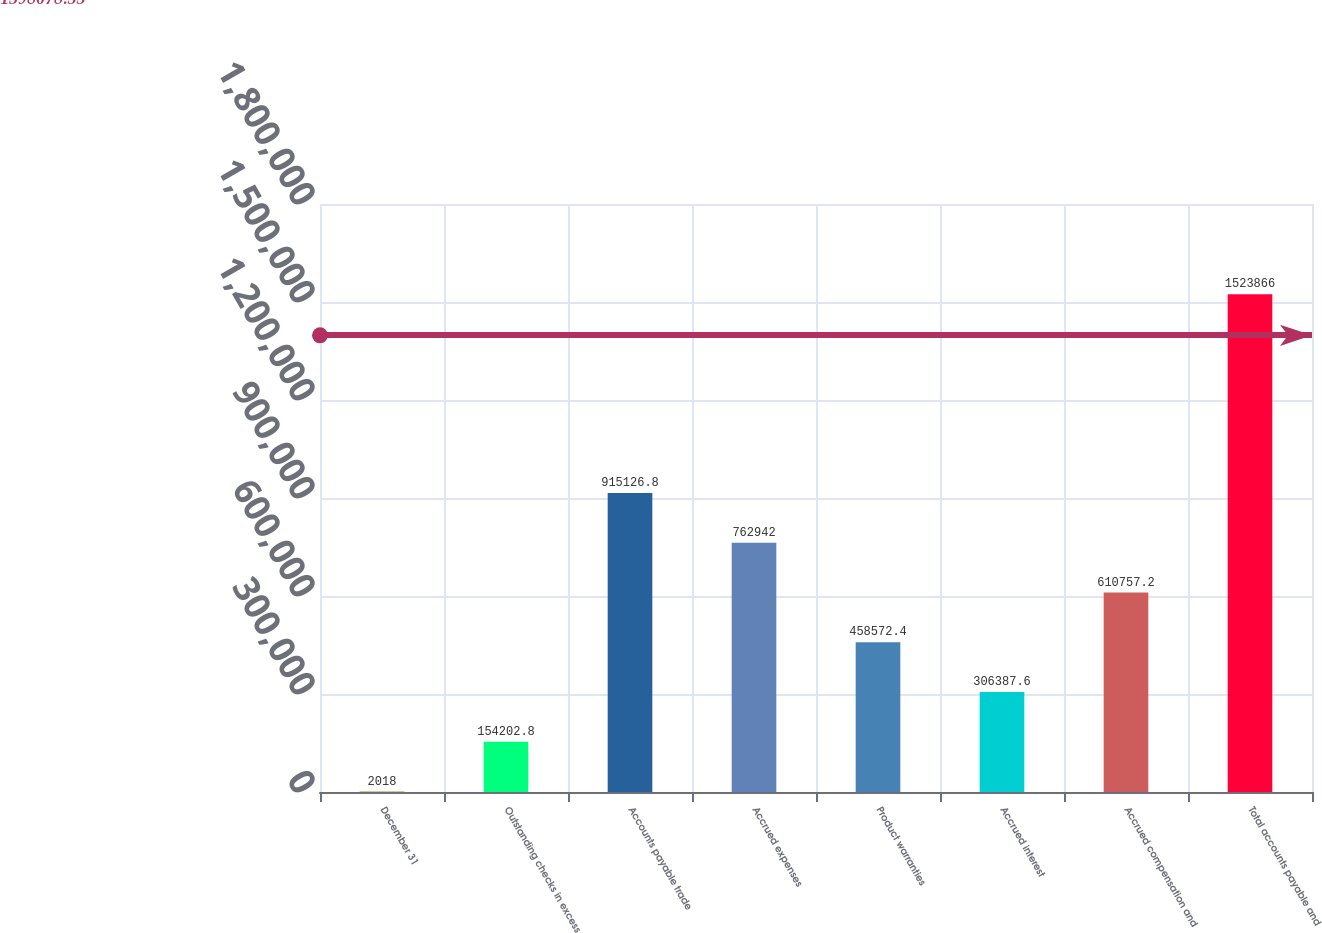<chart> <loc_0><loc_0><loc_500><loc_500><bar_chart><fcel>December 31<fcel>Outstanding checks in excess<fcel>Accounts payable trade<fcel>Accrued expenses<fcel>Product warranties<fcel>Accrued interest<fcel>Accrued compensation and<fcel>Total accounts payable and<nl><fcel>2018<fcel>154203<fcel>915127<fcel>762942<fcel>458572<fcel>306388<fcel>610757<fcel>1.52387e+06<nl></chart> 